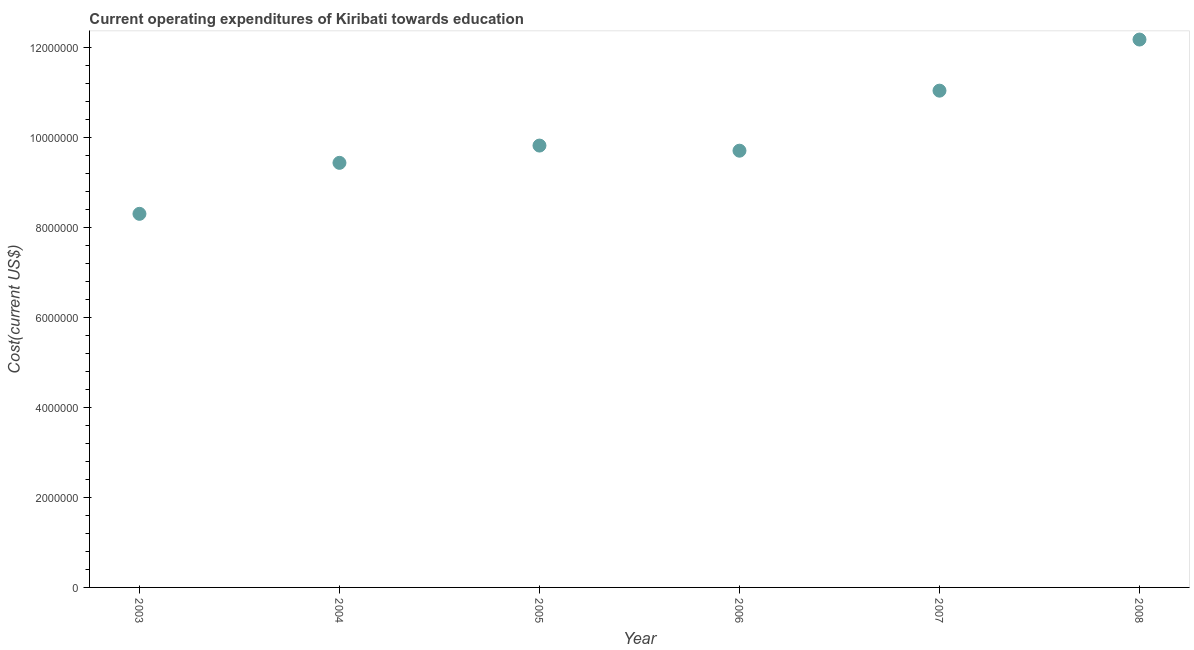What is the education expenditure in 2007?
Ensure brevity in your answer.  1.11e+07. Across all years, what is the maximum education expenditure?
Offer a terse response. 1.22e+07. Across all years, what is the minimum education expenditure?
Make the answer very short. 8.31e+06. In which year was the education expenditure maximum?
Keep it short and to the point. 2008. What is the sum of the education expenditure?
Offer a very short reply. 6.05e+07. What is the difference between the education expenditure in 2003 and 2008?
Offer a terse response. -3.88e+06. What is the average education expenditure per year?
Ensure brevity in your answer.  1.01e+07. What is the median education expenditure?
Keep it short and to the point. 9.77e+06. Do a majority of the years between 2006 and 2007 (inclusive) have education expenditure greater than 4400000 US$?
Keep it short and to the point. Yes. What is the ratio of the education expenditure in 2004 to that in 2006?
Your response must be concise. 0.97. Is the difference between the education expenditure in 2006 and 2007 greater than the difference between any two years?
Provide a short and direct response. No. What is the difference between the highest and the second highest education expenditure?
Provide a succinct answer. 1.14e+06. Is the sum of the education expenditure in 2004 and 2007 greater than the maximum education expenditure across all years?
Provide a succinct answer. Yes. What is the difference between the highest and the lowest education expenditure?
Offer a terse response. 3.88e+06. Does the education expenditure monotonically increase over the years?
Provide a short and direct response. No. How many dotlines are there?
Your response must be concise. 1. How many years are there in the graph?
Provide a succinct answer. 6. What is the difference between two consecutive major ticks on the Y-axis?
Offer a terse response. 2.00e+06. Are the values on the major ticks of Y-axis written in scientific E-notation?
Keep it short and to the point. No. Does the graph contain any zero values?
Offer a very short reply. No. Does the graph contain grids?
Your answer should be compact. No. What is the title of the graph?
Offer a very short reply. Current operating expenditures of Kiribati towards education. What is the label or title of the Y-axis?
Offer a terse response. Cost(current US$). What is the Cost(current US$) in 2003?
Keep it short and to the point. 8.31e+06. What is the Cost(current US$) in 2004?
Your answer should be compact. 9.44e+06. What is the Cost(current US$) in 2005?
Offer a very short reply. 9.83e+06. What is the Cost(current US$) in 2006?
Give a very brief answer. 9.72e+06. What is the Cost(current US$) in 2007?
Offer a terse response. 1.11e+07. What is the Cost(current US$) in 2008?
Make the answer very short. 1.22e+07. What is the difference between the Cost(current US$) in 2003 and 2004?
Provide a succinct answer. -1.13e+06. What is the difference between the Cost(current US$) in 2003 and 2005?
Your answer should be very brief. -1.52e+06. What is the difference between the Cost(current US$) in 2003 and 2006?
Your answer should be very brief. -1.40e+06. What is the difference between the Cost(current US$) in 2003 and 2007?
Your answer should be compact. -2.74e+06. What is the difference between the Cost(current US$) in 2003 and 2008?
Ensure brevity in your answer.  -3.88e+06. What is the difference between the Cost(current US$) in 2004 and 2005?
Keep it short and to the point. -3.84e+05. What is the difference between the Cost(current US$) in 2004 and 2006?
Your response must be concise. -2.70e+05. What is the difference between the Cost(current US$) in 2004 and 2007?
Offer a terse response. -1.61e+06. What is the difference between the Cost(current US$) in 2004 and 2008?
Ensure brevity in your answer.  -2.74e+06. What is the difference between the Cost(current US$) in 2005 and 2006?
Provide a short and direct response. 1.14e+05. What is the difference between the Cost(current US$) in 2005 and 2007?
Provide a short and direct response. -1.22e+06. What is the difference between the Cost(current US$) in 2005 and 2008?
Offer a terse response. -2.36e+06. What is the difference between the Cost(current US$) in 2006 and 2007?
Your response must be concise. -1.34e+06. What is the difference between the Cost(current US$) in 2006 and 2008?
Give a very brief answer. -2.47e+06. What is the difference between the Cost(current US$) in 2007 and 2008?
Give a very brief answer. -1.14e+06. What is the ratio of the Cost(current US$) in 2003 to that in 2004?
Your answer should be compact. 0.88. What is the ratio of the Cost(current US$) in 2003 to that in 2005?
Ensure brevity in your answer.  0.85. What is the ratio of the Cost(current US$) in 2003 to that in 2006?
Your answer should be very brief. 0.85. What is the ratio of the Cost(current US$) in 2003 to that in 2007?
Your response must be concise. 0.75. What is the ratio of the Cost(current US$) in 2003 to that in 2008?
Offer a terse response. 0.68. What is the ratio of the Cost(current US$) in 2004 to that in 2005?
Provide a short and direct response. 0.96. What is the ratio of the Cost(current US$) in 2004 to that in 2007?
Provide a short and direct response. 0.85. What is the ratio of the Cost(current US$) in 2004 to that in 2008?
Offer a terse response. 0.78. What is the ratio of the Cost(current US$) in 2005 to that in 2006?
Ensure brevity in your answer.  1.01. What is the ratio of the Cost(current US$) in 2005 to that in 2007?
Make the answer very short. 0.89. What is the ratio of the Cost(current US$) in 2005 to that in 2008?
Give a very brief answer. 0.81. What is the ratio of the Cost(current US$) in 2006 to that in 2007?
Your response must be concise. 0.88. What is the ratio of the Cost(current US$) in 2006 to that in 2008?
Make the answer very short. 0.8. What is the ratio of the Cost(current US$) in 2007 to that in 2008?
Your answer should be compact. 0.91. 